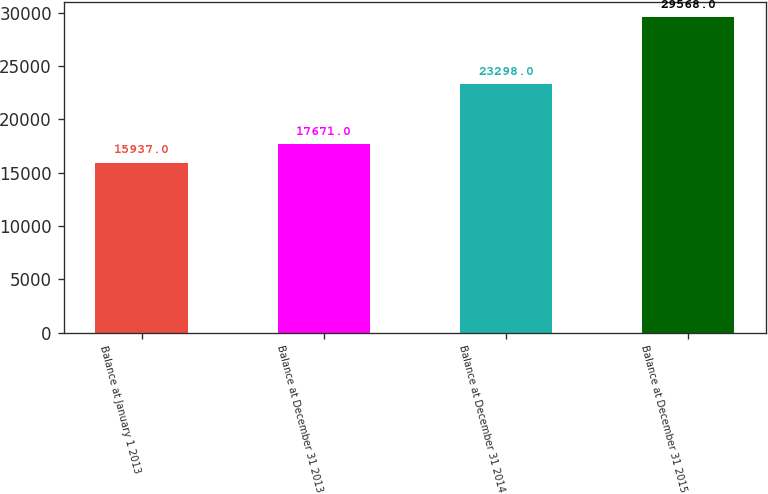Convert chart. <chart><loc_0><loc_0><loc_500><loc_500><bar_chart><fcel>Balance at January 1 2013<fcel>Balance at December 31 2013<fcel>Balance at December 31 2014<fcel>Balance at December 31 2015<nl><fcel>15937<fcel>17671<fcel>23298<fcel>29568<nl></chart> 